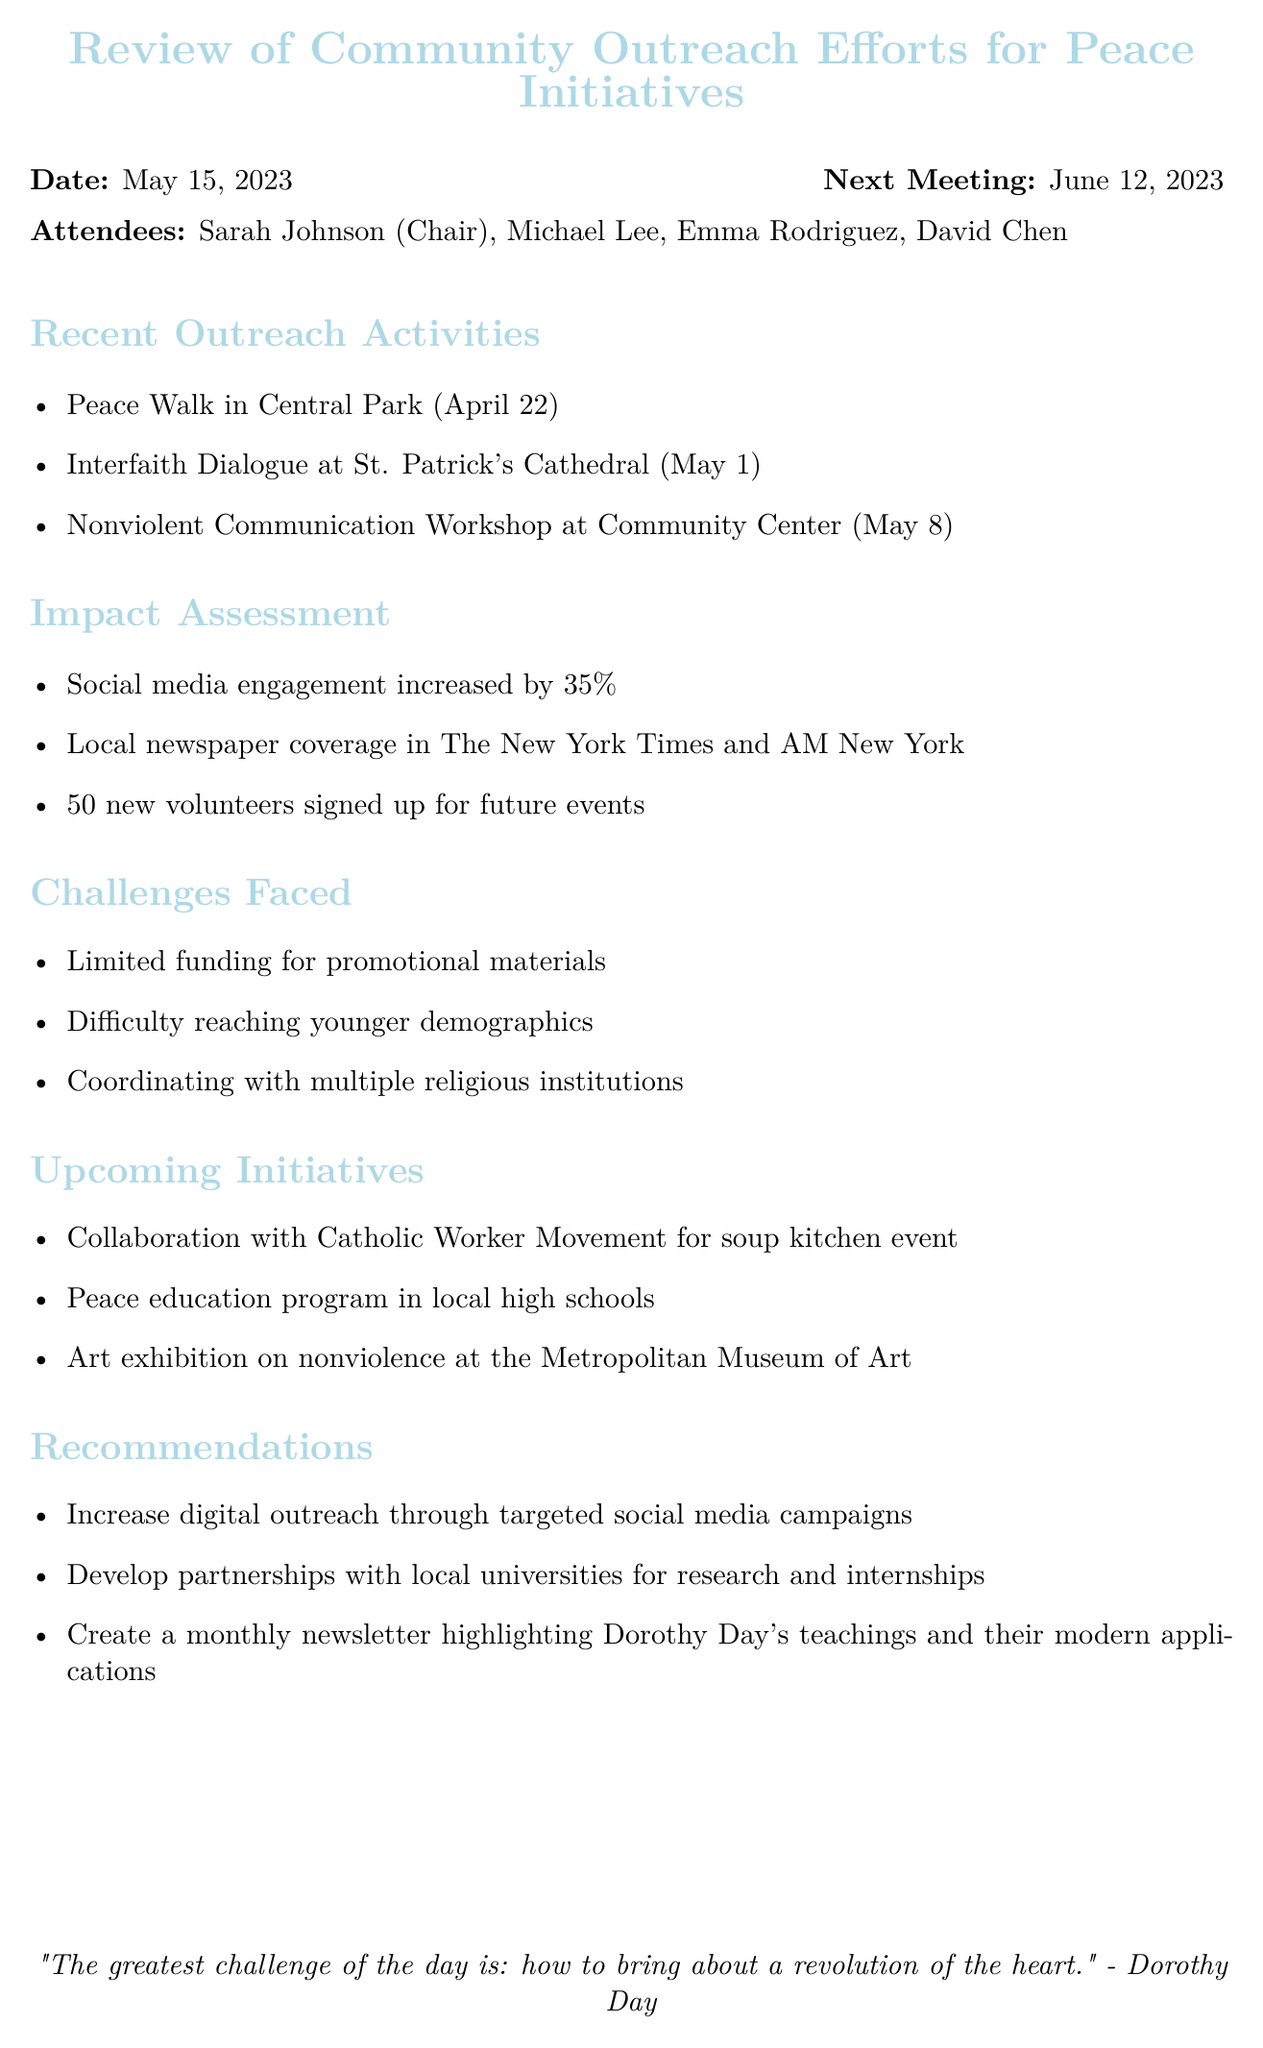What was the date of the meeting? The date of the meeting is explicitly mentioned in the document.
Answer: May 15, 2023 Who chaired the meeting? The Chair of the meeting is listed among the attendees.
Answer: Sarah Johnson How many new volunteers signed up? The number of new volunteers is provided in the impact assessment section.
Answer: 50 What is a challenge faced by the group? One of the challenges is listed under the challenges faced section.
Answer: Limited funding for promotional materials What is one upcoming initiative? Examples of upcoming initiatives are listed in their respective section.
Answer: Collaboration with Catholic Worker Movement for soup kitchen event What increased by 35 percent? The information pertains to the impact assessment.
Answer: Social media engagement Who is responsible for contacting the Metropolitan Museum of Art? The action items specify who is responsible for tasks.
Answer: Emma When is the next meeting scheduled? The next meeting date is stated at the beginning of the document.
Answer: June 12, 2023 What type of outreach activity occurred on May 1? The specific activity is mentioned in the recent outreach activities section.
Answer: Interfaith Dialogue at St. Patrick's Cathedral 